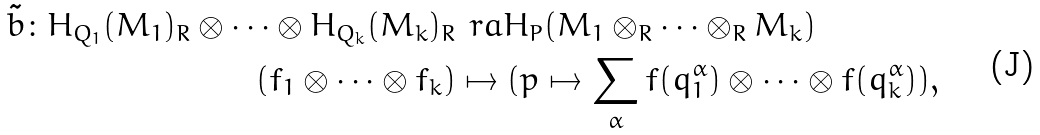<formula> <loc_0><loc_0><loc_500><loc_500>\tilde { b } \colon H _ { Q _ { 1 } } ( M _ { 1 } ) _ { R } \otimes \cdots \otimes H _ { Q _ { k } } ( M _ { k } ) _ { R } & \ r a H _ { P } ( M _ { 1 } \otimes _ { R } \cdots \otimes _ { R } M _ { k } ) \\ ( f _ { 1 } \otimes \cdots \otimes f _ { k } ) & \mapsto ( p \mapsto \sum _ { \alpha } f ( q _ { 1 } ^ { \alpha } ) \otimes \cdots \otimes f ( q _ { k } ^ { \alpha } ) ) ,</formula> 